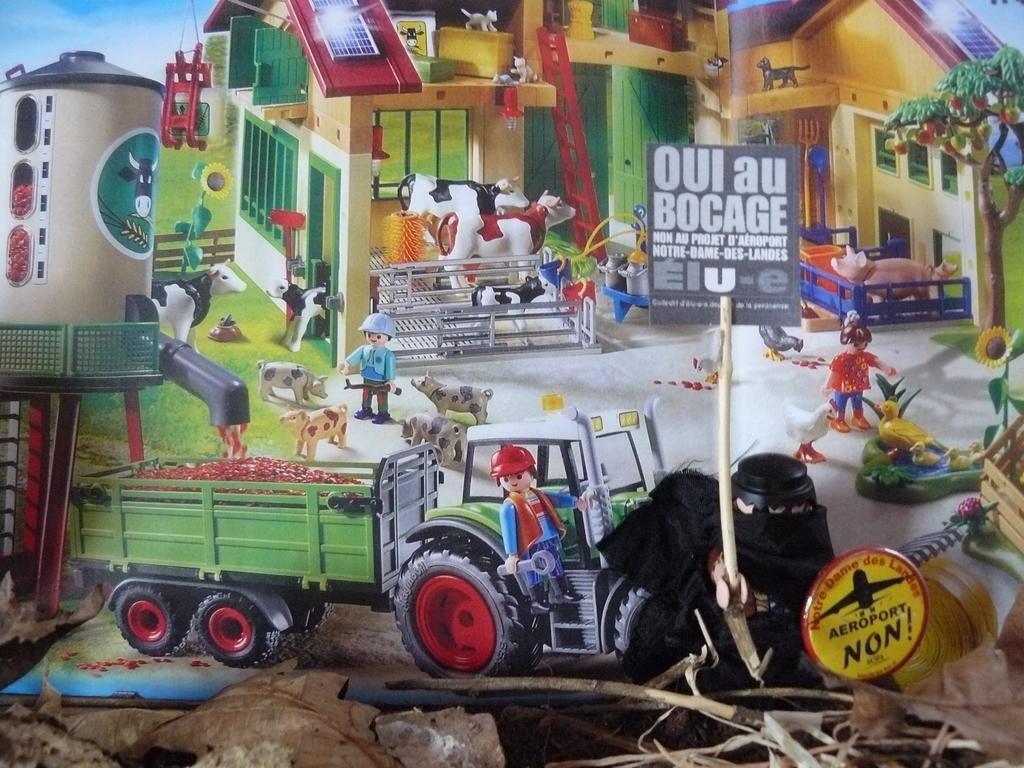How would you summarize this image in a sentence or two? In this picture there is a poster, on this poster we can see people, tree, vehicle, animals, house, flowers, grass, sky and objects. At the bottom of the image we can see leaves, branches and there is a mascot holding a stick with board. 